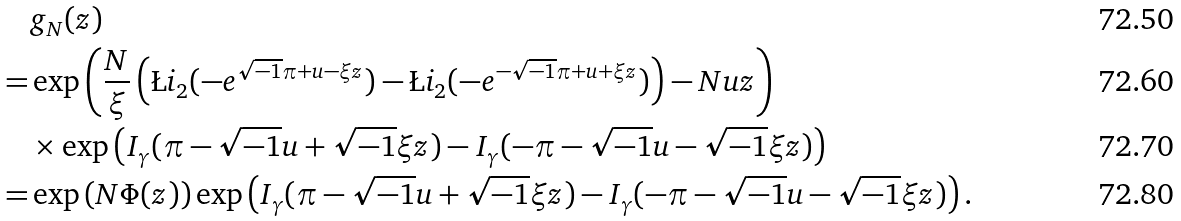Convert formula to latex. <formula><loc_0><loc_0><loc_500><loc_500>& g _ { N } ( z ) \\ = & \exp \left ( \frac { N } { \xi } \left ( \L i _ { 2 } ( - e ^ { \sqrt { - 1 } \pi + u - \xi z } ) - \L i _ { 2 } ( - e ^ { - \sqrt { - 1 } \pi + u + \xi z } ) \right ) - N u z \right ) \\ & \times \exp \left ( I _ { \gamma } ( \pi - \sqrt { - 1 } u + \sqrt { - 1 } \xi z ) - I _ { \gamma } ( - \pi - \sqrt { - 1 } u - \sqrt { - 1 } \xi z ) \right ) \\ = & \exp \left ( N \Phi ( z ) \right ) \exp \left ( I _ { \gamma } ( \pi - \sqrt { - 1 } u + \sqrt { - 1 } \xi z ) - I _ { \gamma } ( - \pi - \sqrt { - 1 } u - \sqrt { - 1 } \xi z ) \right ) .</formula> 